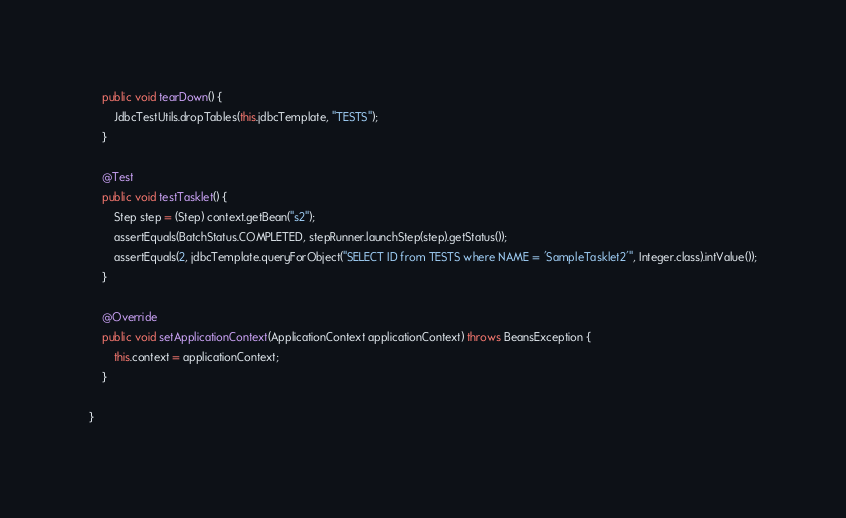Convert code to text. <code><loc_0><loc_0><loc_500><loc_500><_Java_>	public void tearDown() {
		JdbcTestUtils.dropTables(this.jdbcTemplate, "TESTS");
	}

	@Test
	public void testTasklet() {
		Step step = (Step) context.getBean("s2");
		assertEquals(BatchStatus.COMPLETED, stepRunner.launchStep(step).getStatus());
		assertEquals(2, jdbcTemplate.queryForObject("SELECT ID from TESTS where NAME = 'SampleTasklet2'", Integer.class).intValue());
	}

    @Override
	public void setApplicationContext(ApplicationContext applicationContext) throws BeansException {
		this.context = applicationContext;
	}

}
</code> 